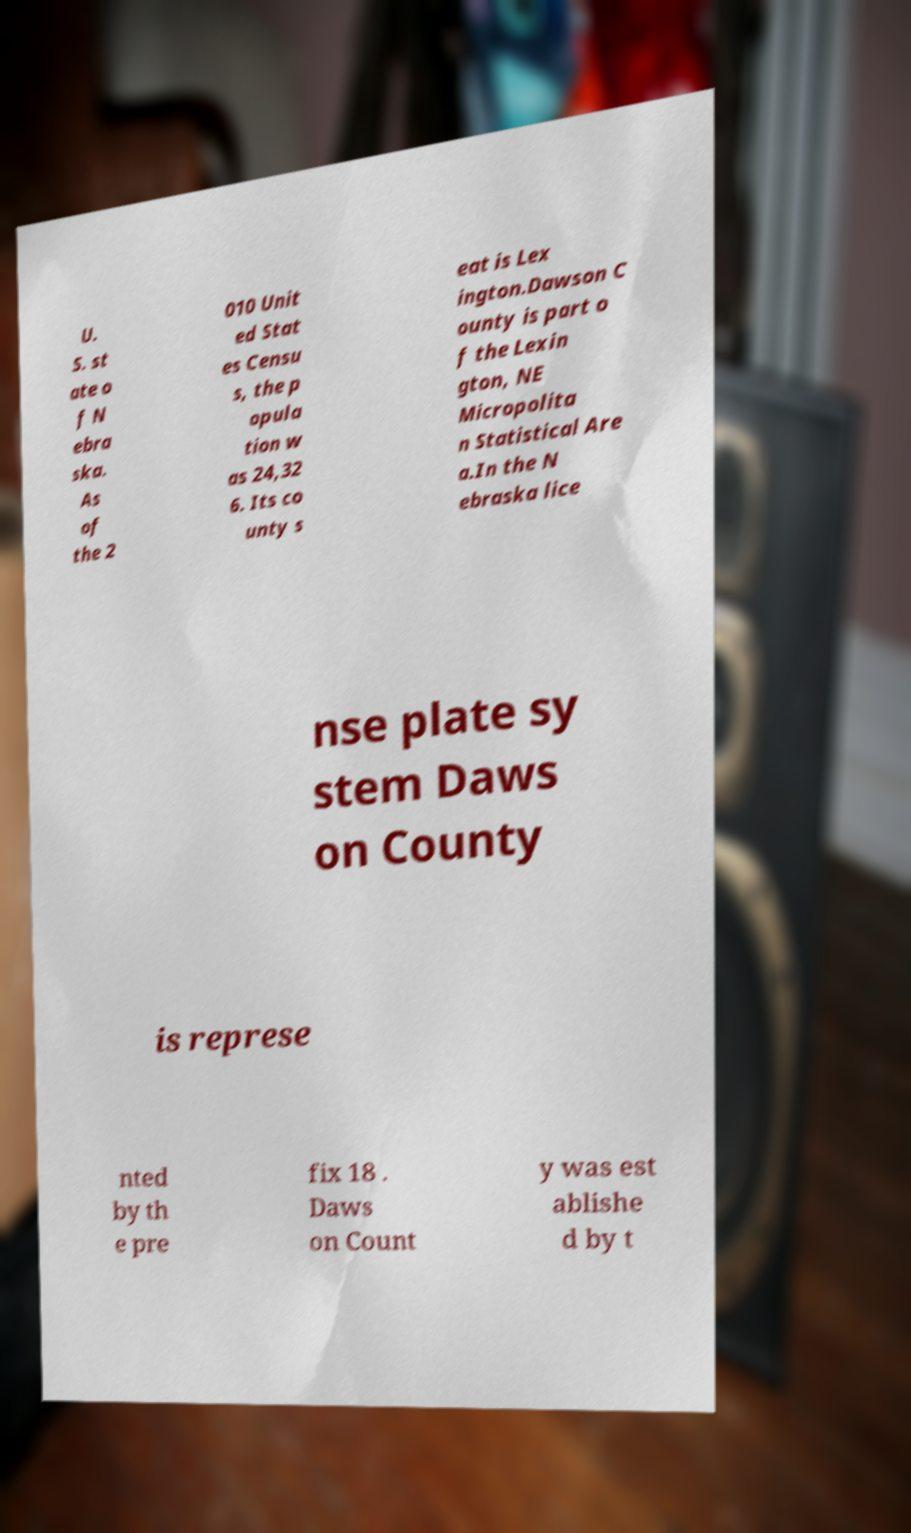Can you accurately transcribe the text from the provided image for me? U. S. st ate o f N ebra ska. As of the 2 010 Unit ed Stat es Censu s, the p opula tion w as 24,32 6. Its co unty s eat is Lex ington.Dawson C ounty is part o f the Lexin gton, NE Micropolita n Statistical Are a.In the N ebraska lice nse plate sy stem Daws on County is represe nted by th e pre fix 18 . Daws on Count y was est ablishe d by t 